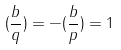<formula> <loc_0><loc_0><loc_500><loc_500>( \frac { b } { q } ) = - ( \frac { b } { p } ) = 1</formula> 